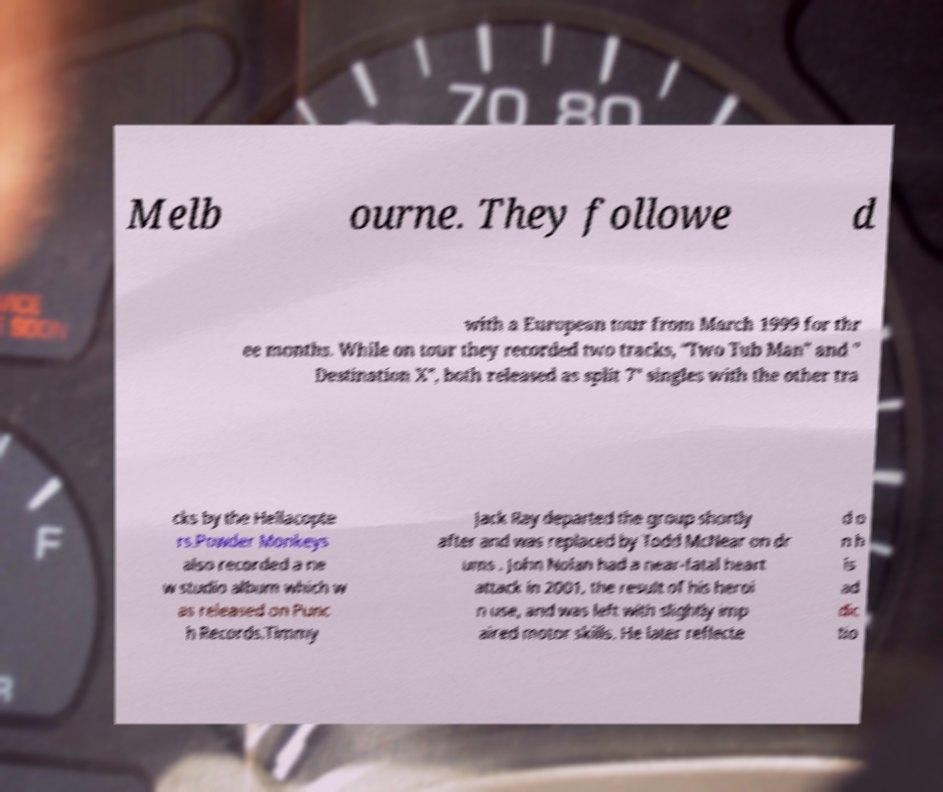There's text embedded in this image that I need extracted. Can you transcribe it verbatim? Melb ourne. They followe d with a European tour from March 1999 for thr ee months. While on tour they recorded two tracks, "Two Tub Man" and " Destination X", both released as split 7" singles with the other tra cks by the Hellacopte rs.Powder Monkeys also recorded a ne w studio album which w as released on Punc h Records.Timmy Jack Ray departed the group shortly after and was replaced by Todd McNear on dr ums . John Nolan had a near-fatal heart attack in 2001, the result of his heroi n use, and was left with slightly imp aired motor skills. He later reflecte d o n h is ad dic tio 